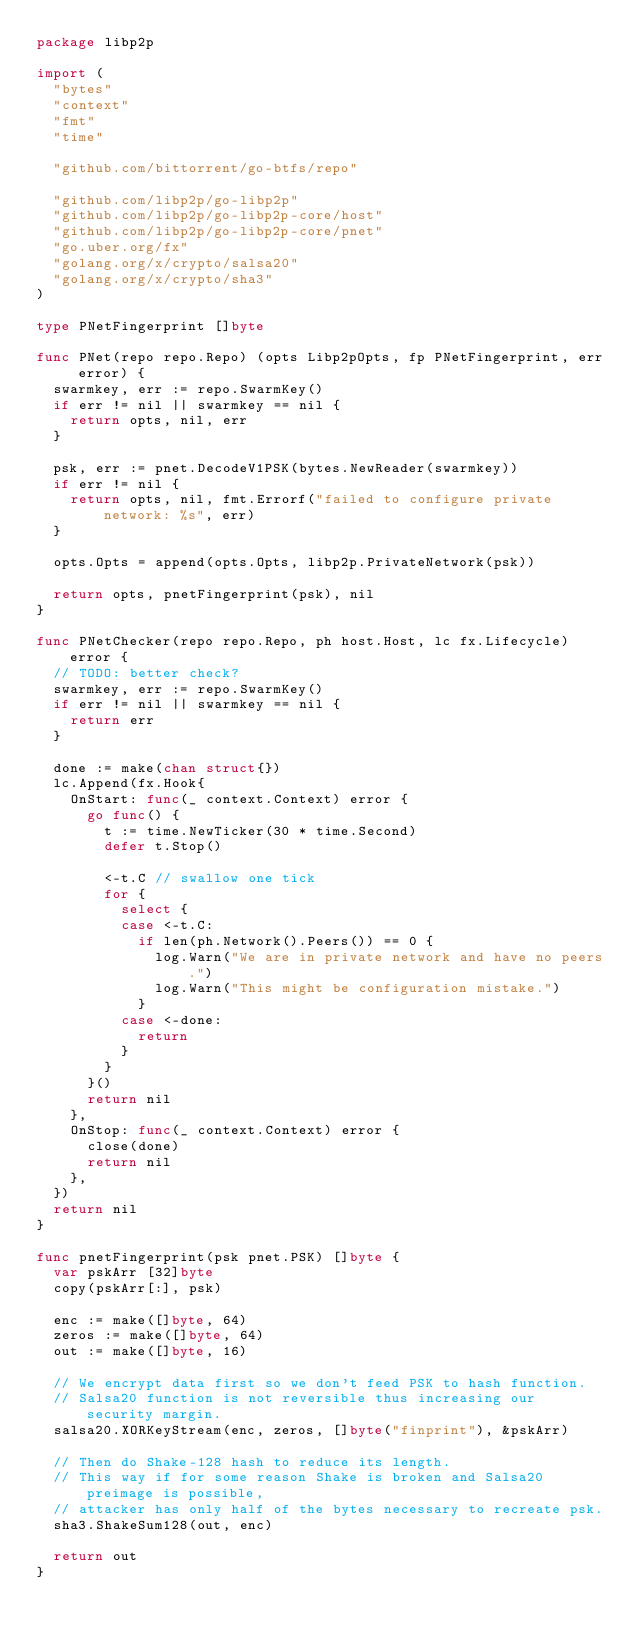Convert code to text. <code><loc_0><loc_0><loc_500><loc_500><_Go_>package libp2p

import (
	"bytes"
	"context"
	"fmt"
	"time"

	"github.com/bittorrent/go-btfs/repo"

	"github.com/libp2p/go-libp2p"
	"github.com/libp2p/go-libp2p-core/host"
	"github.com/libp2p/go-libp2p-core/pnet"
	"go.uber.org/fx"
	"golang.org/x/crypto/salsa20"
	"golang.org/x/crypto/sha3"
)

type PNetFingerprint []byte

func PNet(repo repo.Repo) (opts Libp2pOpts, fp PNetFingerprint, err error) {
	swarmkey, err := repo.SwarmKey()
	if err != nil || swarmkey == nil {
		return opts, nil, err
	}

	psk, err := pnet.DecodeV1PSK(bytes.NewReader(swarmkey))
	if err != nil {
		return opts, nil, fmt.Errorf("failed to configure private network: %s", err)
	}

	opts.Opts = append(opts.Opts, libp2p.PrivateNetwork(psk))

	return opts, pnetFingerprint(psk), nil
}

func PNetChecker(repo repo.Repo, ph host.Host, lc fx.Lifecycle) error {
	// TODO: better check?
	swarmkey, err := repo.SwarmKey()
	if err != nil || swarmkey == nil {
		return err
	}

	done := make(chan struct{})
	lc.Append(fx.Hook{
		OnStart: func(_ context.Context) error {
			go func() {
				t := time.NewTicker(30 * time.Second)
				defer t.Stop()

				<-t.C // swallow one tick
				for {
					select {
					case <-t.C:
						if len(ph.Network().Peers()) == 0 {
							log.Warn("We are in private network and have no peers.")
							log.Warn("This might be configuration mistake.")
						}
					case <-done:
						return
					}
				}
			}()
			return nil
		},
		OnStop: func(_ context.Context) error {
			close(done)
			return nil
		},
	})
	return nil
}

func pnetFingerprint(psk pnet.PSK) []byte {
	var pskArr [32]byte
	copy(pskArr[:], psk)

	enc := make([]byte, 64)
	zeros := make([]byte, 64)
	out := make([]byte, 16)

	// We encrypt data first so we don't feed PSK to hash function.
	// Salsa20 function is not reversible thus increasing our security margin.
	salsa20.XORKeyStream(enc, zeros, []byte("finprint"), &pskArr)

	// Then do Shake-128 hash to reduce its length.
	// This way if for some reason Shake is broken and Salsa20 preimage is possible,
	// attacker has only half of the bytes necessary to recreate psk.
	sha3.ShakeSum128(out, enc)

	return out
}
</code> 